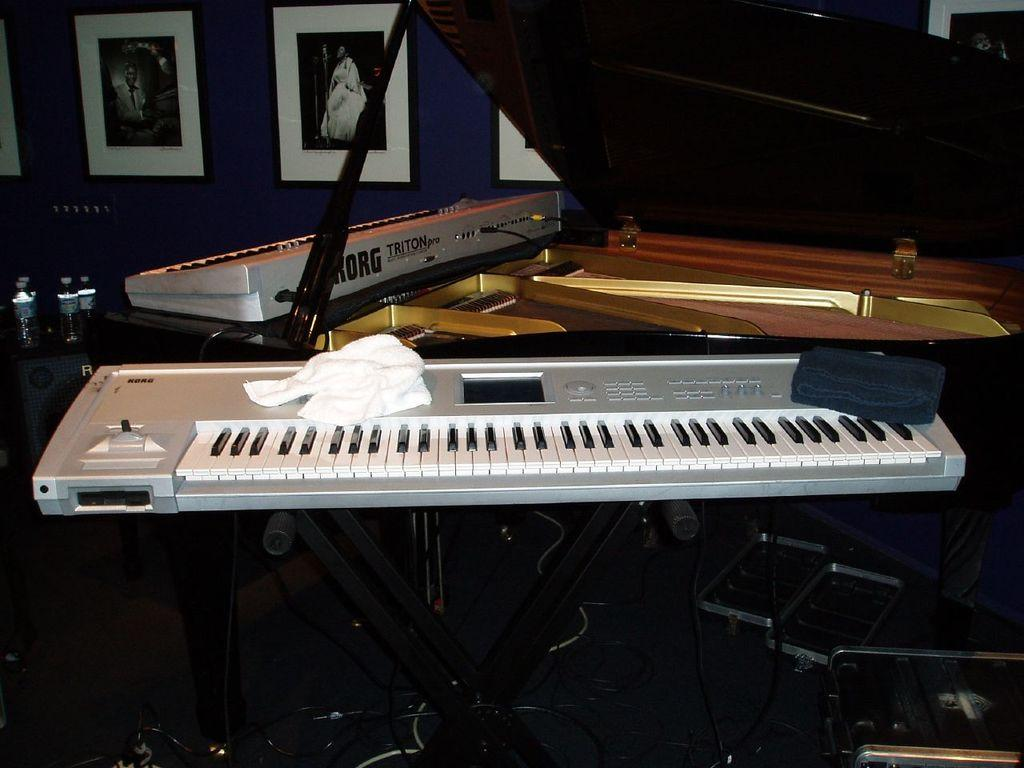What musical instruments are on the table in the image? There are pianos on a table in the image. What other objects can be seen in the image? There are bottles visible in the image. What is hanging on the wall in the image? There are portraits on the wall in the image. What is covering one of the pianos? There is a cloth on one of the pianos in the image. What type of agreement is being discussed by the flock of birds in the image? There are no birds present in the image, so there is no discussion or agreement taking place. 